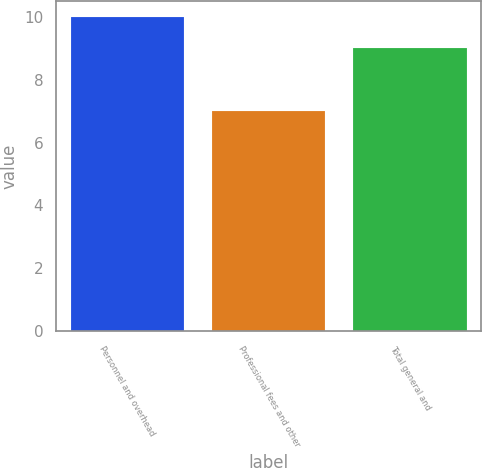<chart> <loc_0><loc_0><loc_500><loc_500><bar_chart><fcel>Personnel and overhead<fcel>Professional fees and other<fcel>Total general and<nl><fcel>10<fcel>7<fcel>9<nl></chart> 